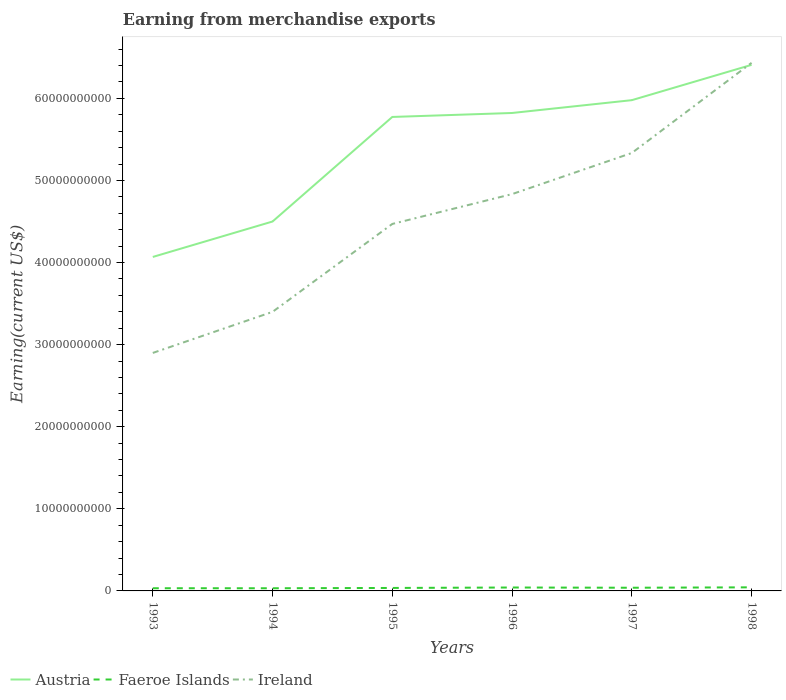How many different coloured lines are there?
Ensure brevity in your answer.  3. Does the line corresponding to Austria intersect with the line corresponding to Faeroe Islands?
Provide a short and direct response. No. Is the number of lines equal to the number of legend labels?
Make the answer very short. Yes. Across all years, what is the maximum amount earned from merchandise exports in Austria?
Offer a terse response. 4.07e+1. What is the total amount earned from merchandise exports in Faeroe Islands in the graph?
Offer a terse response. -3.60e+07. What is the difference between the highest and the second highest amount earned from merchandise exports in Austria?
Ensure brevity in your answer.  2.34e+1. How many lines are there?
Provide a short and direct response. 3. Are the values on the major ticks of Y-axis written in scientific E-notation?
Give a very brief answer. No. Does the graph contain grids?
Ensure brevity in your answer.  No. How are the legend labels stacked?
Make the answer very short. Horizontal. What is the title of the graph?
Offer a terse response. Earning from merchandise exports. Does "Hong Kong" appear as one of the legend labels in the graph?
Your answer should be very brief. No. What is the label or title of the X-axis?
Give a very brief answer. Years. What is the label or title of the Y-axis?
Ensure brevity in your answer.  Earning(current US$). What is the Earning(current US$) in Austria in 1993?
Your answer should be very brief. 4.07e+1. What is the Earning(current US$) of Faeroe Islands in 1993?
Ensure brevity in your answer.  3.27e+08. What is the Earning(current US$) in Ireland in 1993?
Ensure brevity in your answer.  2.90e+1. What is the Earning(current US$) of Austria in 1994?
Offer a very short reply. 4.50e+1. What is the Earning(current US$) in Faeroe Islands in 1994?
Provide a succinct answer. 3.26e+08. What is the Earning(current US$) of Ireland in 1994?
Offer a terse response. 3.40e+1. What is the Earning(current US$) in Austria in 1995?
Keep it short and to the point. 5.77e+1. What is the Earning(current US$) of Faeroe Islands in 1995?
Offer a terse response. 3.62e+08. What is the Earning(current US$) of Ireland in 1995?
Offer a very short reply. 4.47e+1. What is the Earning(current US$) in Austria in 1996?
Ensure brevity in your answer.  5.82e+1. What is the Earning(current US$) of Faeroe Islands in 1996?
Your answer should be very brief. 4.16e+08. What is the Earning(current US$) in Ireland in 1996?
Ensure brevity in your answer.  4.83e+1. What is the Earning(current US$) in Austria in 1997?
Offer a very short reply. 5.98e+1. What is the Earning(current US$) in Faeroe Islands in 1997?
Provide a succinct answer. 3.88e+08. What is the Earning(current US$) of Ireland in 1997?
Give a very brief answer. 5.33e+1. What is the Earning(current US$) in Austria in 1998?
Your answer should be compact. 6.41e+1. What is the Earning(current US$) of Faeroe Islands in 1998?
Your answer should be compact. 4.37e+08. What is the Earning(current US$) of Ireland in 1998?
Give a very brief answer. 6.43e+1. Across all years, what is the maximum Earning(current US$) of Austria?
Keep it short and to the point. 6.41e+1. Across all years, what is the maximum Earning(current US$) in Faeroe Islands?
Make the answer very short. 4.37e+08. Across all years, what is the maximum Earning(current US$) in Ireland?
Give a very brief answer. 6.43e+1. Across all years, what is the minimum Earning(current US$) of Austria?
Your answer should be very brief. 4.07e+1. Across all years, what is the minimum Earning(current US$) of Faeroe Islands?
Your answer should be very brief. 3.26e+08. Across all years, what is the minimum Earning(current US$) of Ireland?
Provide a succinct answer. 2.90e+1. What is the total Earning(current US$) of Austria in the graph?
Keep it short and to the point. 3.26e+11. What is the total Earning(current US$) in Faeroe Islands in the graph?
Your answer should be very brief. 2.26e+09. What is the total Earning(current US$) in Ireland in the graph?
Offer a very short reply. 2.74e+11. What is the difference between the Earning(current US$) in Austria in 1993 and that in 1994?
Give a very brief answer. -4.32e+09. What is the difference between the Earning(current US$) of Ireland in 1993 and that in 1994?
Provide a succinct answer. -5.00e+09. What is the difference between the Earning(current US$) in Austria in 1993 and that in 1995?
Give a very brief answer. -1.71e+1. What is the difference between the Earning(current US$) in Faeroe Islands in 1993 and that in 1995?
Give a very brief answer. -3.50e+07. What is the difference between the Earning(current US$) in Ireland in 1993 and that in 1995?
Your answer should be compact. -1.57e+1. What is the difference between the Earning(current US$) in Austria in 1993 and that in 1996?
Provide a succinct answer. -1.75e+1. What is the difference between the Earning(current US$) of Faeroe Islands in 1993 and that in 1996?
Keep it short and to the point. -8.90e+07. What is the difference between the Earning(current US$) in Ireland in 1993 and that in 1996?
Make the answer very short. -1.93e+1. What is the difference between the Earning(current US$) in Austria in 1993 and that in 1997?
Provide a succinct answer. -1.91e+1. What is the difference between the Earning(current US$) in Faeroe Islands in 1993 and that in 1997?
Ensure brevity in your answer.  -6.10e+07. What is the difference between the Earning(current US$) in Ireland in 1993 and that in 1997?
Offer a very short reply. -2.44e+1. What is the difference between the Earning(current US$) in Austria in 1993 and that in 1998?
Ensure brevity in your answer.  -2.34e+1. What is the difference between the Earning(current US$) in Faeroe Islands in 1993 and that in 1998?
Your answer should be very brief. -1.10e+08. What is the difference between the Earning(current US$) of Ireland in 1993 and that in 1998?
Your answer should be compact. -3.53e+1. What is the difference between the Earning(current US$) in Austria in 1994 and that in 1995?
Provide a succinct answer. -1.27e+1. What is the difference between the Earning(current US$) of Faeroe Islands in 1994 and that in 1995?
Your response must be concise. -3.60e+07. What is the difference between the Earning(current US$) in Ireland in 1994 and that in 1995?
Provide a short and direct response. -1.07e+1. What is the difference between the Earning(current US$) of Austria in 1994 and that in 1996?
Ensure brevity in your answer.  -1.32e+1. What is the difference between the Earning(current US$) in Faeroe Islands in 1994 and that in 1996?
Provide a succinct answer. -9.00e+07. What is the difference between the Earning(current US$) of Ireland in 1994 and that in 1996?
Your answer should be compact. -1.43e+1. What is the difference between the Earning(current US$) in Austria in 1994 and that in 1997?
Make the answer very short. -1.48e+1. What is the difference between the Earning(current US$) of Faeroe Islands in 1994 and that in 1997?
Offer a terse response. -6.20e+07. What is the difference between the Earning(current US$) in Ireland in 1994 and that in 1997?
Your response must be concise. -1.94e+1. What is the difference between the Earning(current US$) of Austria in 1994 and that in 1998?
Your answer should be very brief. -1.91e+1. What is the difference between the Earning(current US$) in Faeroe Islands in 1994 and that in 1998?
Give a very brief answer. -1.11e+08. What is the difference between the Earning(current US$) in Ireland in 1994 and that in 1998?
Offer a very short reply. -3.03e+1. What is the difference between the Earning(current US$) of Austria in 1995 and that in 1996?
Offer a very short reply. -4.84e+08. What is the difference between the Earning(current US$) of Faeroe Islands in 1995 and that in 1996?
Give a very brief answer. -5.40e+07. What is the difference between the Earning(current US$) in Ireland in 1995 and that in 1996?
Provide a short and direct response. -3.63e+09. What is the difference between the Earning(current US$) of Austria in 1995 and that in 1997?
Make the answer very short. -2.05e+09. What is the difference between the Earning(current US$) of Faeroe Islands in 1995 and that in 1997?
Ensure brevity in your answer.  -2.60e+07. What is the difference between the Earning(current US$) in Ireland in 1995 and that in 1997?
Your answer should be very brief. -8.64e+09. What is the difference between the Earning(current US$) in Austria in 1995 and that in 1998?
Provide a short and direct response. -6.35e+09. What is the difference between the Earning(current US$) in Faeroe Islands in 1995 and that in 1998?
Give a very brief answer. -7.50e+07. What is the difference between the Earning(current US$) of Ireland in 1995 and that in 1998?
Give a very brief answer. -1.96e+1. What is the difference between the Earning(current US$) in Austria in 1996 and that in 1997?
Provide a short and direct response. -1.56e+09. What is the difference between the Earning(current US$) of Faeroe Islands in 1996 and that in 1997?
Provide a succinct answer. 2.80e+07. What is the difference between the Earning(current US$) of Ireland in 1996 and that in 1997?
Offer a terse response. -5.01e+09. What is the difference between the Earning(current US$) of Austria in 1996 and that in 1998?
Offer a terse response. -5.86e+09. What is the difference between the Earning(current US$) in Faeroe Islands in 1996 and that in 1998?
Make the answer very short. -2.10e+07. What is the difference between the Earning(current US$) of Ireland in 1996 and that in 1998?
Keep it short and to the point. -1.60e+1. What is the difference between the Earning(current US$) of Austria in 1997 and that in 1998?
Provide a succinct answer. -4.30e+09. What is the difference between the Earning(current US$) in Faeroe Islands in 1997 and that in 1998?
Provide a short and direct response. -4.90e+07. What is the difference between the Earning(current US$) in Ireland in 1997 and that in 1998?
Your response must be concise. -1.10e+1. What is the difference between the Earning(current US$) of Austria in 1993 and the Earning(current US$) of Faeroe Islands in 1994?
Ensure brevity in your answer.  4.04e+1. What is the difference between the Earning(current US$) in Austria in 1993 and the Earning(current US$) in Ireland in 1994?
Give a very brief answer. 6.69e+09. What is the difference between the Earning(current US$) of Faeroe Islands in 1993 and the Earning(current US$) of Ireland in 1994?
Your answer should be compact. -3.37e+1. What is the difference between the Earning(current US$) in Austria in 1993 and the Earning(current US$) in Faeroe Islands in 1995?
Your response must be concise. 4.03e+1. What is the difference between the Earning(current US$) in Austria in 1993 and the Earning(current US$) in Ireland in 1995?
Provide a short and direct response. -4.02e+09. What is the difference between the Earning(current US$) in Faeroe Islands in 1993 and the Earning(current US$) in Ireland in 1995?
Give a very brief answer. -4.44e+1. What is the difference between the Earning(current US$) in Austria in 1993 and the Earning(current US$) in Faeroe Islands in 1996?
Keep it short and to the point. 4.03e+1. What is the difference between the Earning(current US$) in Austria in 1993 and the Earning(current US$) in Ireland in 1996?
Keep it short and to the point. -7.65e+09. What is the difference between the Earning(current US$) in Faeroe Islands in 1993 and the Earning(current US$) in Ireland in 1996?
Offer a very short reply. -4.80e+1. What is the difference between the Earning(current US$) of Austria in 1993 and the Earning(current US$) of Faeroe Islands in 1997?
Your response must be concise. 4.03e+1. What is the difference between the Earning(current US$) in Austria in 1993 and the Earning(current US$) in Ireland in 1997?
Make the answer very short. -1.27e+1. What is the difference between the Earning(current US$) in Faeroe Islands in 1993 and the Earning(current US$) in Ireland in 1997?
Offer a terse response. -5.30e+1. What is the difference between the Earning(current US$) in Austria in 1993 and the Earning(current US$) in Faeroe Islands in 1998?
Offer a very short reply. 4.02e+1. What is the difference between the Earning(current US$) in Austria in 1993 and the Earning(current US$) in Ireland in 1998?
Make the answer very short. -2.36e+1. What is the difference between the Earning(current US$) in Faeroe Islands in 1993 and the Earning(current US$) in Ireland in 1998?
Ensure brevity in your answer.  -6.40e+1. What is the difference between the Earning(current US$) of Austria in 1994 and the Earning(current US$) of Faeroe Islands in 1995?
Your response must be concise. 4.46e+1. What is the difference between the Earning(current US$) in Austria in 1994 and the Earning(current US$) in Ireland in 1995?
Make the answer very short. 2.97e+08. What is the difference between the Earning(current US$) in Faeroe Islands in 1994 and the Earning(current US$) in Ireland in 1995?
Keep it short and to the point. -4.44e+1. What is the difference between the Earning(current US$) of Austria in 1994 and the Earning(current US$) of Faeroe Islands in 1996?
Offer a very short reply. 4.46e+1. What is the difference between the Earning(current US$) in Austria in 1994 and the Earning(current US$) in Ireland in 1996?
Keep it short and to the point. -3.34e+09. What is the difference between the Earning(current US$) of Faeroe Islands in 1994 and the Earning(current US$) of Ireland in 1996?
Ensure brevity in your answer.  -4.80e+1. What is the difference between the Earning(current US$) in Austria in 1994 and the Earning(current US$) in Faeroe Islands in 1997?
Give a very brief answer. 4.46e+1. What is the difference between the Earning(current US$) of Austria in 1994 and the Earning(current US$) of Ireland in 1997?
Offer a terse response. -8.35e+09. What is the difference between the Earning(current US$) in Faeroe Islands in 1994 and the Earning(current US$) in Ireland in 1997?
Keep it short and to the point. -5.30e+1. What is the difference between the Earning(current US$) in Austria in 1994 and the Earning(current US$) in Faeroe Islands in 1998?
Your response must be concise. 4.46e+1. What is the difference between the Earning(current US$) of Austria in 1994 and the Earning(current US$) of Ireland in 1998?
Your response must be concise. -1.93e+1. What is the difference between the Earning(current US$) of Faeroe Islands in 1994 and the Earning(current US$) of Ireland in 1998?
Ensure brevity in your answer.  -6.40e+1. What is the difference between the Earning(current US$) of Austria in 1995 and the Earning(current US$) of Faeroe Islands in 1996?
Provide a succinct answer. 5.73e+1. What is the difference between the Earning(current US$) in Austria in 1995 and the Earning(current US$) in Ireland in 1996?
Keep it short and to the point. 9.40e+09. What is the difference between the Earning(current US$) in Faeroe Islands in 1995 and the Earning(current US$) in Ireland in 1996?
Offer a terse response. -4.80e+1. What is the difference between the Earning(current US$) in Austria in 1995 and the Earning(current US$) in Faeroe Islands in 1997?
Offer a very short reply. 5.74e+1. What is the difference between the Earning(current US$) of Austria in 1995 and the Earning(current US$) of Ireland in 1997?
Your answer should be very brief. 4.39e+09. What is the difference between the Earning(current US$) of Faeroe Islands in 1995 and the Earning(current US$) of Ireland in 1997?
Offer a terse response. -5.30e+1. What is the difference between the Earning(current US$) in Austria in 1995 and the Earning(current US$) in Faeroe Islands in 1998?
Make the answer very short. 5.73e+1. What is the difference between the Earning(current US$) of Austria in 1995 and the Earning(current US$) of Ireland in 1998?
Your response must be concise. -6.59e+09. What is the difference between the Earning(current US$) of Faeroe Islands in 1995 and the Earning(current US$) of Ireland in 1998?
Your answer should be compact. -6.40e+1. What is the difference between the Earning(current US$) of Austria in 1996 and the Earning(current US$) of Faeroe Islands in 1997?
Provide a short and direct response. 5.78e+1. What is the difference between the Earning(current US$) in Austria in 1996 and the Earning(current US$) in Ireland in 1997?
Make the answer very short. 4.87e+09. What is the difference between the Earning(current US$) in Faeroe Islands in 1996 and the Earning(current US$) in Ireland in 1997?
Ensure brevity in your answer.  -5.29e+1. What is the difference between the Earning(current US$) in Austria in 1996 and the Earning(current US$) in Faeroe Islands in 1998?
Offer a terse response. 5.78e+1. What is the difference between the Earning(current US$) in Austria in 1996 and the Earning(current US$) in Ireland in 1998?
Keep it short and to the point. -6.11e+09. What is the difference between the Earning(current US$) of Faeroe Islands in 1996 and the Earning(current US$) of Ireland in 1998?
Make the answer very short. -6.39e+1. What is the difference between the Earning(current US$) in Austria in 1997 and the Earning(current US$) in Faeroe Islands in 1998?
Your answer should be compact. 5.93e+1. What is the difference between the Earning(current US$) in Austria in 1997 and the Earning(current US$) in Ireland in 1998?
Give a very brief answer. -4.55e+09. What is the difference between the Earning(current US$) of Faeroe Islands in 1997 and the Earning(current US$) of Ireland in 1998?
Offer a terse response. -6.39e+1. What is the average Earning(current US$) of Austria per year?
Give a very brief answer. 5.43e+1. What is the average Earning(current US$) of Faeroe Islands per year?
Offer a very short reply. 3.76e+08. What is the average Earning(current US$) in Ireland per year?
Offer a very short reply. 4.56e+1. In the year 1993, what is the difference between the Earning(current US$) in Austria and Earning(current US$) in Faeroe Islands?
Offer a very short reply. 4.04e+1. In the year 1993, what is the difference between the Earning(current US$) of Austria and Earning(current US$) of Ireland?
Make the answer very short. 1.17e+1. In the year 1993, what is the difference between the Earning(current US$) of Faeroe Islands and Earning(current US$) of Ireland?
Your response must be concise. -2.87e+1. In the year 1994, what is the difference between the Earning(current US$) in Austria and Earning(current US$) in Faeroe Islands?
Your answer should be very brief. 4.47e+1. In the year 1994, what is the difference between the Earning(current US$) of Austria and Earning(current US$) of Ireland?
Offer a very short reply. 1.10e+1. In the year 1994, what is the difference between the Earning(current US$) in Faeroe Islands and Earning(current US$) in Ireland?
Provide a succinct answer. -3.37e+1. In the year 1995, what is the difference between the Earning(current US$) in Austria and Earning(current US$) in Faeroe Islands?
Make the answer very short. 5.74e+1. In the year 1995, what is the difference between the Earning(current US$) in Austria and Earning(current US$) in Ireland?
Provide a succinct answer. 1.30e+1. In the year 1995, what is the difference between the Earning(current US$) of Faeroe Islands and Earning(current US$) of Ireland?
Make the answer very short. -4.43e+1. In the year 1996, what is the difference between the Earning(current US$) in Austria and Earning(current US$) in Faeroe Islands?
Offer a terse response. 5.78e+1. In the year 1996, what is the difference between the Earning(current US$) of Austria and Earning(current US$) of Ireland?
Provide a succinct answer. 9.88e+09. In the year 1996, what is the difference between the Earning(current US$) in Faeroe Islands and Earning(current US$) in Ireland?
Keep it short and to the point. -4.79e+1. In the year 1997, what is the difference between the Earning(current US$) of Austria and Earning(current US$) of Faeroe Islands?
Offer a very short reply. 5.94e+1. In the year 1997, what is the difference between the Earning(current US$) of Austria and Earning(current US$) of Ireland?
Offer a terse response. 6.44e+09. In the year 1997, what is the difference between the Earning(current US$) of Faeroe Islands and Earning(current US$) of Ireland?
Provide a succinct answer. -5.30e+1. In the year 1998, what is the difference between the Earning(current US$) in Austria and Earning(current US$) in Faeroe Islands?
Offer a very short reply. 6.36e+1. In the year 1998, what is the difference between the Earning(current US$) in Austria and Earning(current US$) in Ireland?
Provide a short and direct response. -2.45e+08. In the year 1998, what is the difference between the Earning(current US$) in Faeroe Islands and Earning(current US$) in Ireland?
Give a very brief answer. -6.39e+1. What is the ratio of the Earning(current US$) in Austria in 1993 to that in 1994?
Your answer should be very brief. 0.9. What is the ratio of the Earning(current US$) of Faeroe Islands in 1993 to that in 1994?
Provide a succinct answer. 1. What is the ratio of the Earning(current US$) in Ireland in 1993 to that in 1994?
Your answer should be very brief. 0.85. What is the ratio of the Earning(current US$) of Austria in 1993 to that in 1995?
Give a very brief answer. 0.7. What is the ratio of the Earning(current US$) of Faeroe Islands in 1993 to that in 1995?
Ensure brevity in your answer.  0.9. What is the ratio of the Earning(current US$) of Ireland in 1993 to that in 1995?
Keep it short and to the point. 0.65. What is the ratio of the Earning(current US$) of Austria in 1993 to that in 1996?
Your answer should be compact. 0.7. What is the ratio of the Earning(current US$) of Faeroe Islands in 1993 to that in 1996?
Keep it short and to the point. 0.79. What is the ratio of the Earning(current US$) of Ireland in 1993 to that in 1996?
Provide a succinct answer. 0.6. What is the ratio of the Earning(current US$) of Austria in 1993 to that in 1997?
Offer a terse response. 0.68. What is the ratio of the Earning(current US$) in Faeroe Islands in 1993 to that in 1997?
Keep it short and to the point. 0.84. What is the ratio of the Earning(current US$) in Ireland in 1993 to that in 1997?
Your answer should be very brief. 0.54. What is the ratio of the Earning(current US$) in Austria in 1993 to that in 1998?
Give a very brief answer. 0.63. What is the ratio of the Earning(current US$) in Faeroe Islands in 1993 to that in 1998?
Provide a succinct answer. 0.75. What is the ratio of the Earning(current US$) of Ireland in 1993 to that in 1998?
Provide a short and direct response. 0.45. What is the ratio of the Earning(current US$) in Austria in 1994 to that in 1995?
Keep it short and to the point. 0.78. What is the ratio of the Earning(current US$) of Faeroe Islands in 1994 to that in 1995?
Ensure brevity in your answer.  0.9. What is the ratio of the Earning(current US$) in Ireland in 1994 to that in 1995?
Your answer should be very brief. 0.76. What is the ratio of the Earning(current US$) in Austria in 1994 to that in 1996?
Provide a short and direct response. 0.77. What is the ratio of the Earning(current US$) in Faeroe Islands in 1994 to that in 1996?
Your response must be concise. 0.78. What is the ratio of the Earning(current US$) of Ireland in 1994 to that in 1996?
Offer a terse response. 0.7. What is the ratio of the Earning(current US$) in Austria in 1994 to that in 1997?
Offer a terse response. 0.75. What is the ratio of the Earning(current US$) of Faeroe Islands in 1994 to that in 1997?
Make the answer very short. 0.84. What is the ratio of the Earning(current US$) in Ireland in 1994 to that in 1997?
Your answer should be compact. 0.64. What is the ratio of the Earning(current US$) of Austria in 1994 to that in 1998?
Offer a terse response. 0.7. What is the ratio of the Earning(current US$) of Faeroe Islands in 1994 to that in 1998?
Provide a succinct answer. 0.75. What is the ratio of the Earning(current US$) in Ireland in 1994 to that in 1998?
Provide a short and direct response. 0.53. What is the ratio of the Earning(current US$) of Faeroe Islands in 1995 to that in 1996?
Your response must be concise. 0.87. What is the ratio of the Earning(current US$) in Ireland in 1995 to that in 1996?
Your answer should be very brief. 0.92. What is the ratio of the Earning(current US$) of Austria in 1995 to that in 1997?
Your answer should be compact. 0.97. What is the ratio of the Earning(current US$) in Faeroe Islands in 1995 to that in 1997?
Make the answer very short. 0.93. What is the ratio of the Earning(current US$) of Ireland in 1995 to that in 1997?
Keep it short and to the point. 0.84. What is the ratio of the Earning(current US$) in Austria in 1995 to that in 1998?
Keep it short and to the point. 0.9. What is the ratio of the Earning(current US$) of Faeroe Islands in 1995 to that in 1998?
Give a very brief answer. 0.83. What is the ratio of the Earning(current US$) of Ireland in 1995 to that in 1998?
Give a very brief answer. 0.69. What is the ratio of the Earning(current US$) in Austria in 1996 to that in 1997?
Your response must be concise. 0.97. What is the ratio of the Earning(current US$) in Faeroe Islands in 1996 to that in 1997?
Offer a very short reply. 1.07. What is the ratio of the Earning(current US$) in Ireland in 1996 to that in 1997?
Ensure brevity in your answer.  0.91. What is the ratio of the Earning(current US$) in Austria in 1996 to that in 1998?
Keep it short and to the point. 0.91. What is the ratio of the Earning(current US$) in Faeroe Islands in 1996 to that in 1998?
Offer a very short reply. 0.95. What is the ratio of the Earning(current US$) of Ireland in 1996 to that in 1998?
Ensure brevity in your answer.  0.75. What is the ratio of the Earning(current US$) of Austria in 1997 to that in 1998?
Give a very brief answer. 0.93. What is the ratio of the Earning(current US$) of Faeroe Islands in 1997 to that in 1998?
Offer a very short reply. 0.89. What is the ratio of the Earning(current US$) of Ireland in 1997 to that in 1998?
Give a very brief answer. 0.83. What is the difference between the highest and the second highest Earning(current US$) of Austria?
Offer a very short reply. 4.30e+09. What is the difference between the highest and the second highest Earning(current US$) in Faeroe Islands?
Your response must be concise. 2.10e+07. What is the difference between the highest and the second highest Earning(current US$) in Ireland?
Give a very brief answer. 1.10e+1. What is the difference between the highest and the lowest Earning(current US$) in Austria?
Your answer should be compact. 2.34e+1. What is the difference between the highest and the lowest Earning(current US$) of Faeroe Islands?
Give a very brief answer. 1.11e+08. What is the difference between the highest and the lowest Earning(current US$) in Ireland?
Your answer should be compact. 3.53e+1. 